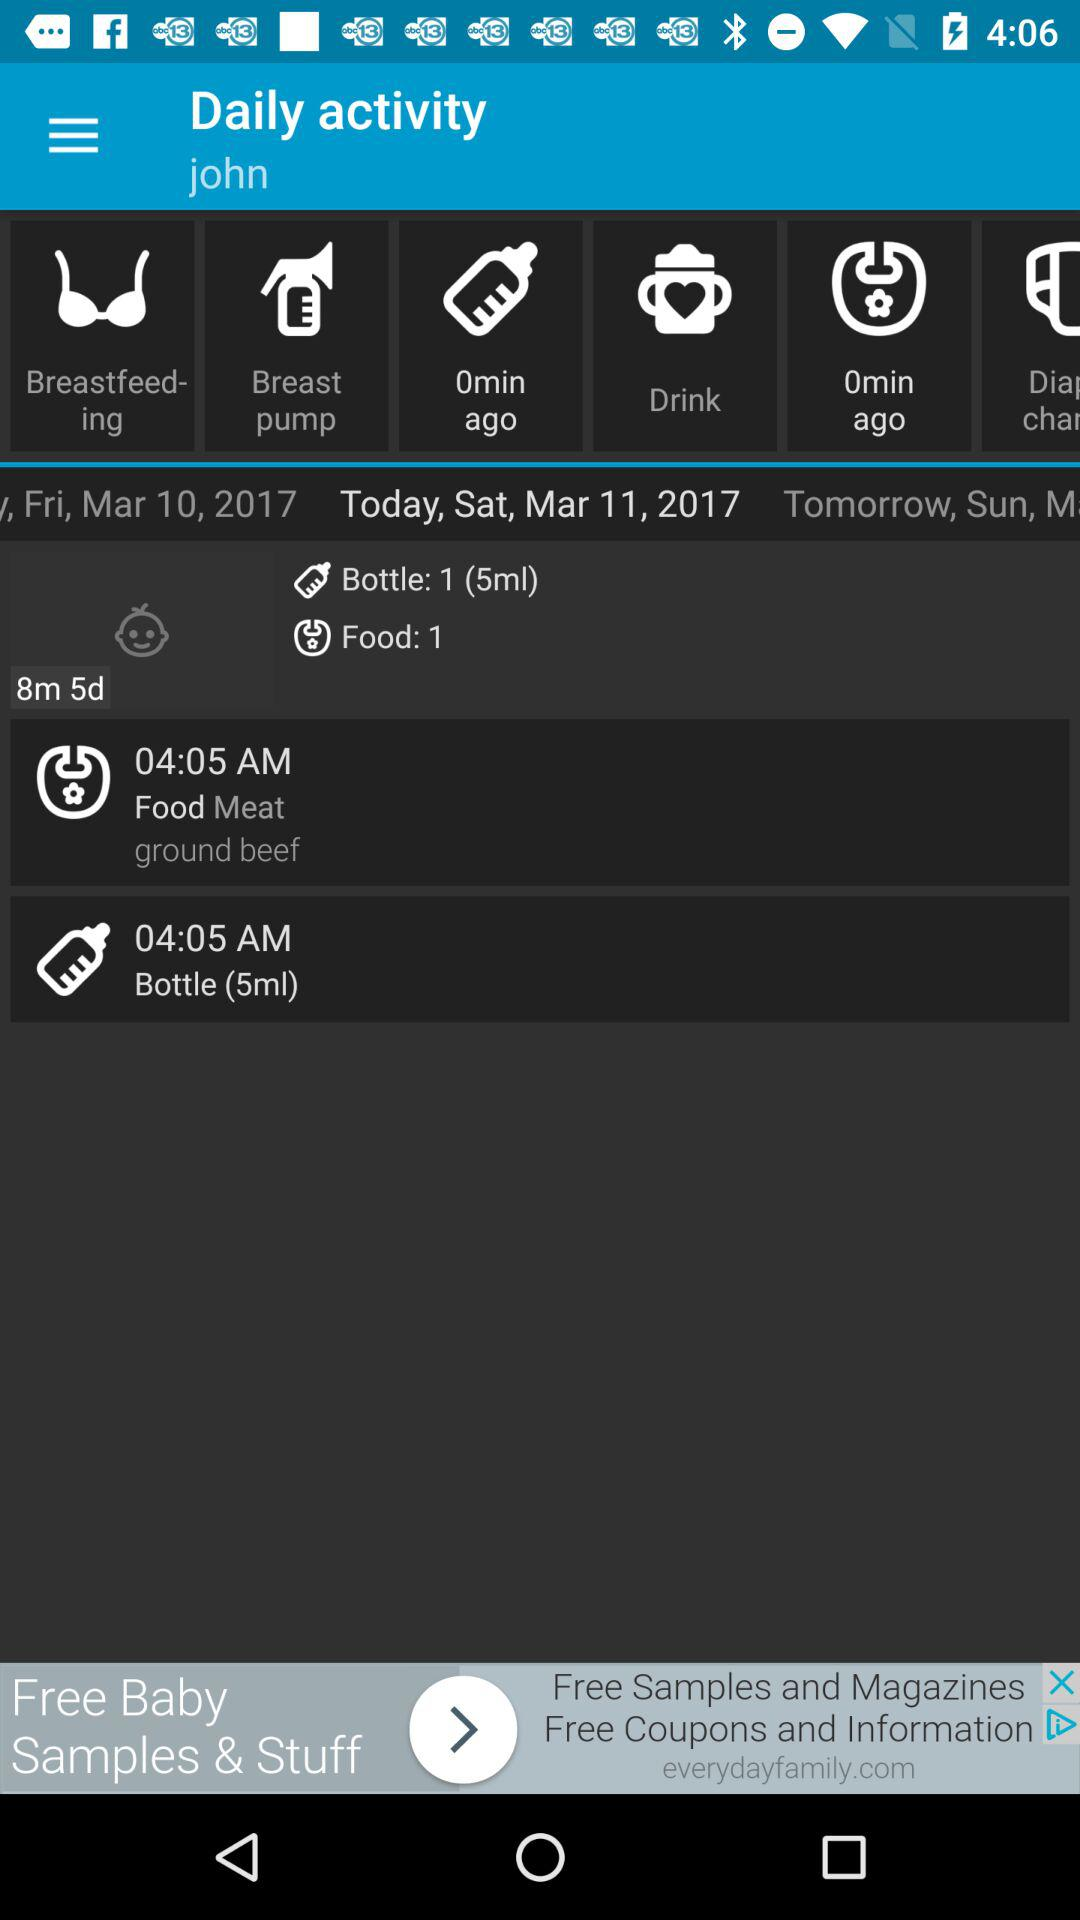What is the number of foods for today? The number of foods is 1. 